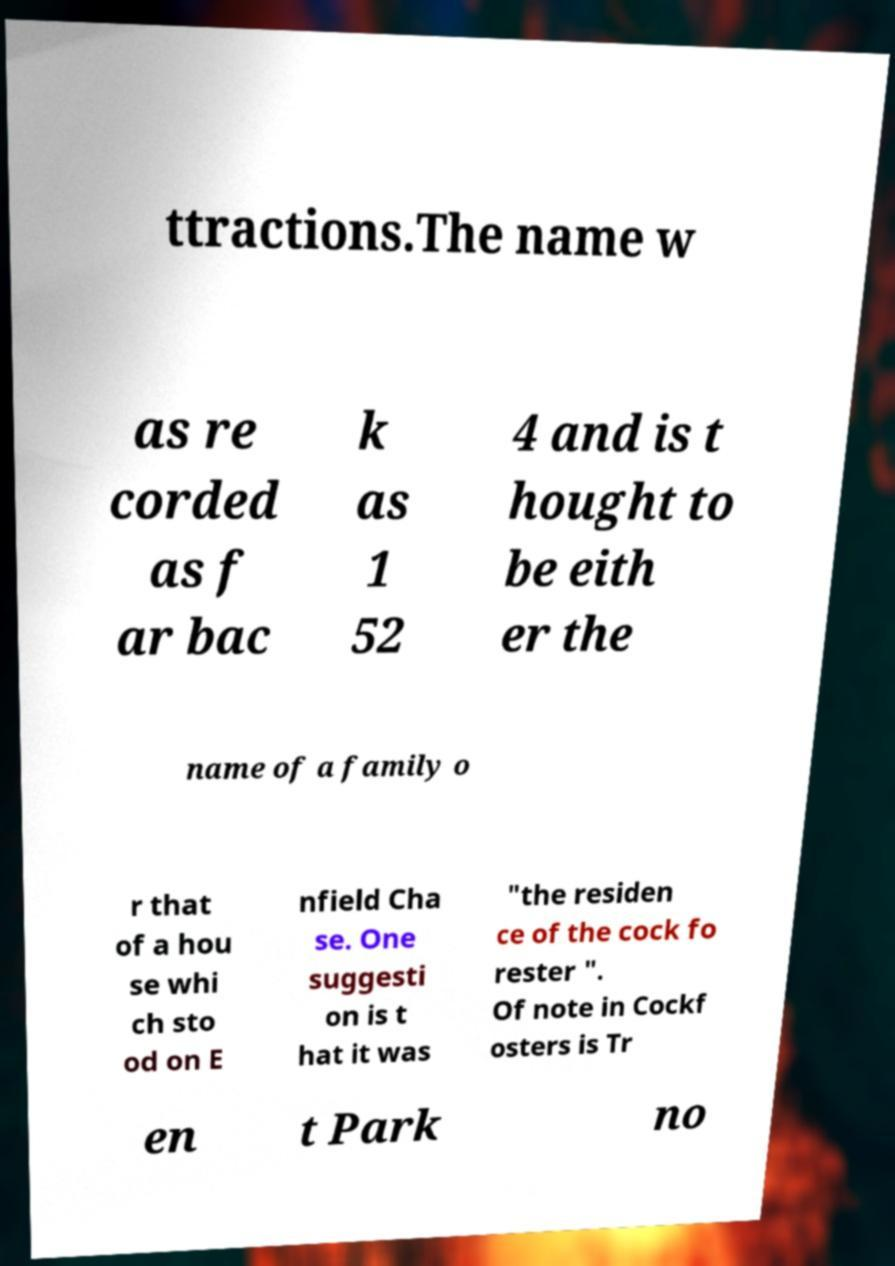Can you read and provide the text displayed in the image?This photo seems to have some interesting text. Can you extract and type it out for me? ttractions.The name w as re corded as f ar bac k as 1 52 4 and is t hought to be eith er the name of a family o r that of a hou se whi ch sto od on E nfield Cha se. One suggesti on is t hat it was "the residen ce of the cock fo rester ". Of note in Cockf osters is Tr en t Park no 